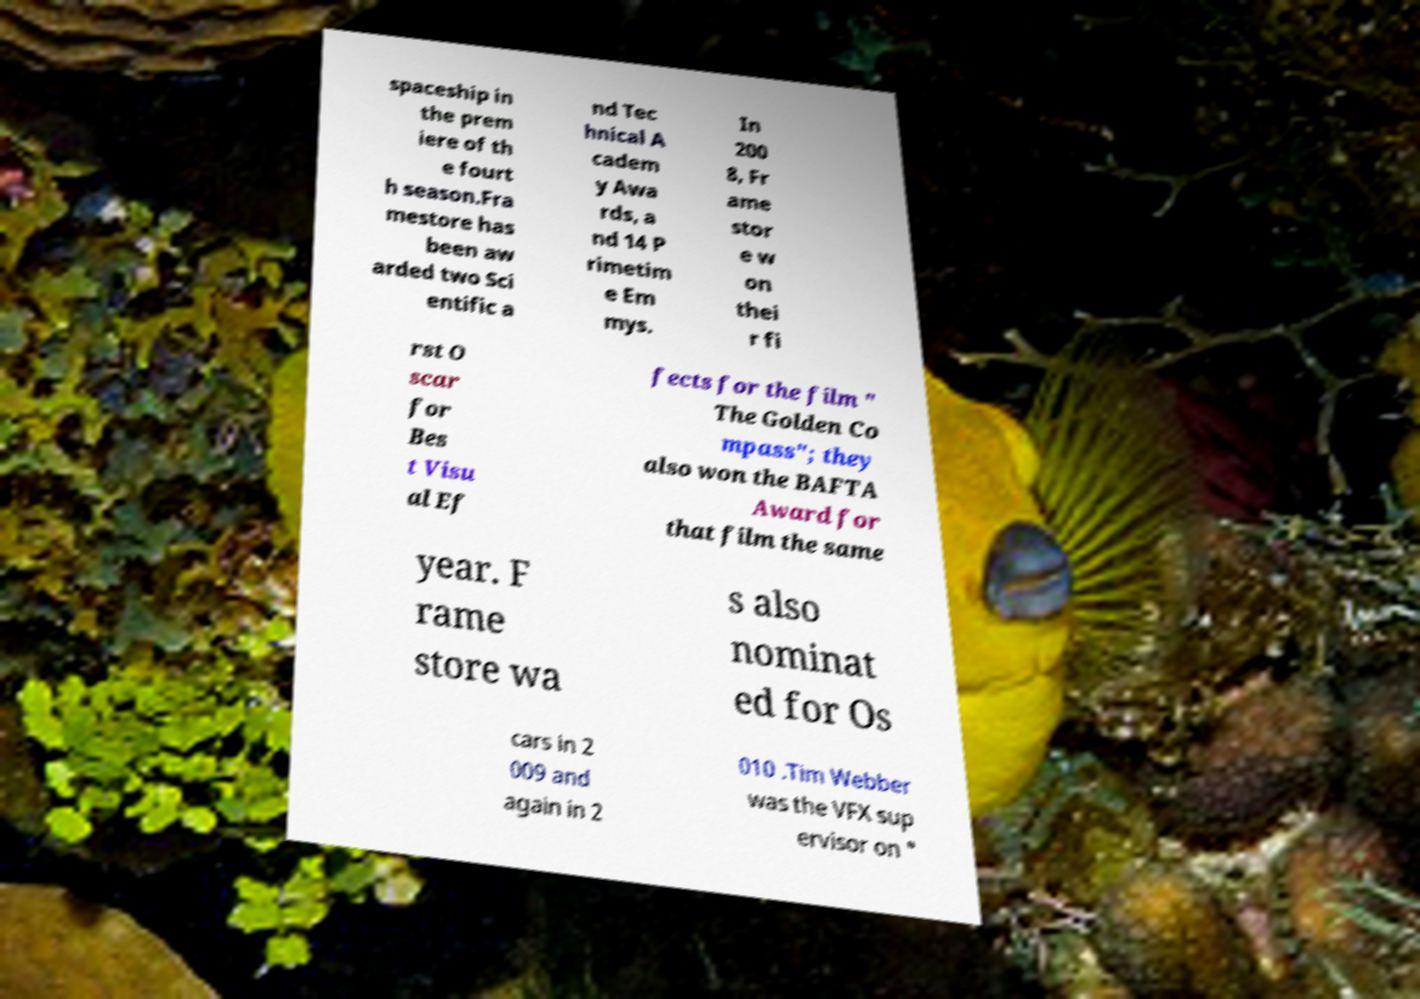Please identify and transcribe the text found in this image. spaceship in the prem iere of th e fourt h season.Fra mestore has been aw arded two Sci entific a nd Tec hnical A cadem y Awa rds, a nd 14 P rimetim e Em mys. In 200 8, Fr ame stor e w on thei r fi rst O scar for Bes t Visu al Ef fects for the film " The Golden Co mpass"; they also won the BAFTA Award for that film the same year. F rame store wa s also nominat ed for Os cars in 2 009 and again in 2 010 .Tim Webber was the VFX sup ervisor on " 